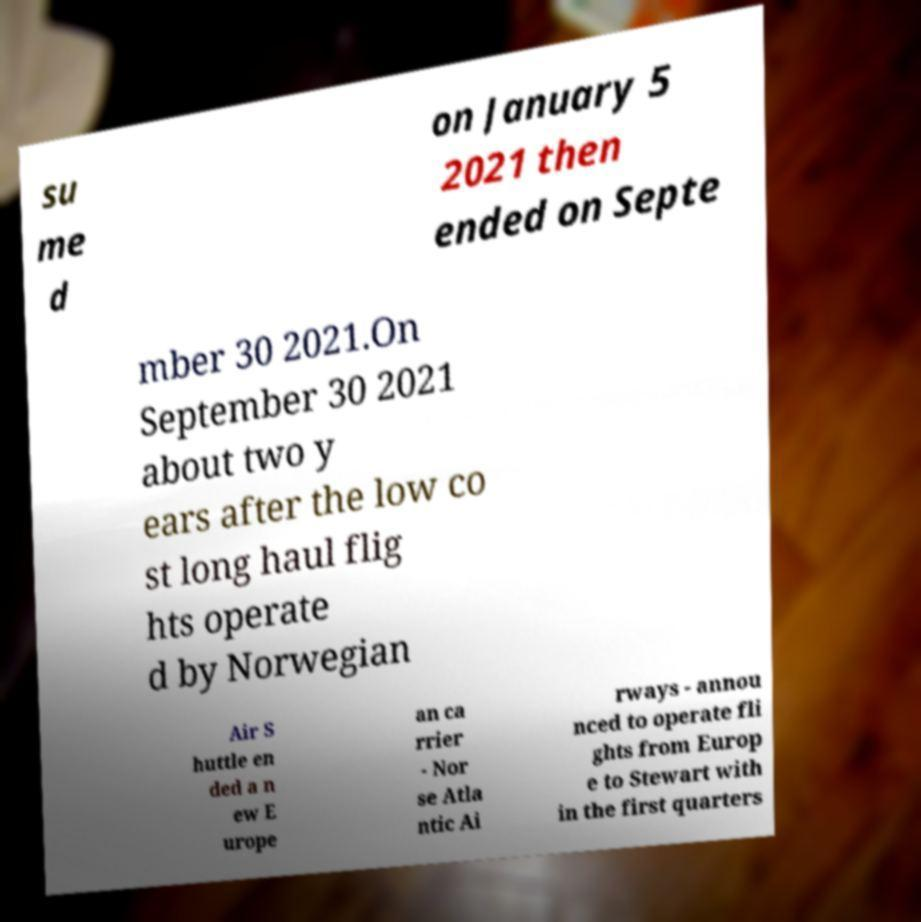Could you extract and type out the text from this image? su me d on January 5 2021 then ended on Septe mber 30 2021.On September 30 2021 about two y ears after the low co st long haul flig hts operate d by Norwegian Air S huttle en ded a n ew E urope an ca rrier - Nor se Atla ntic Ai rways - annou nced to operate fli ghts from Europ e to Stewart with in the first quarters 